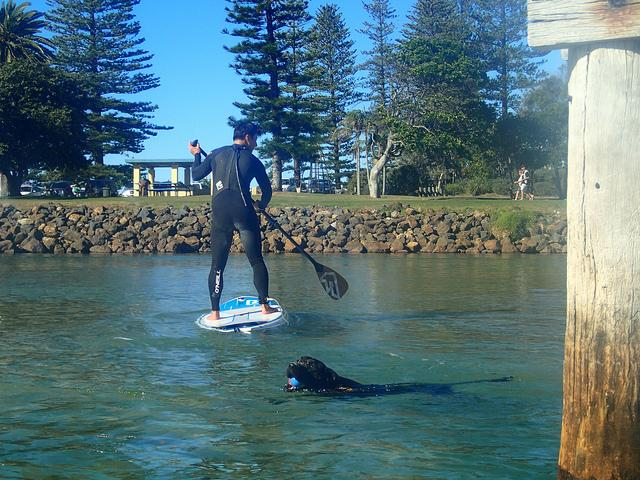What will the dog do with the ball?

Choices:
A) give human
B) break it
C) chase it
D) swallow it give human 